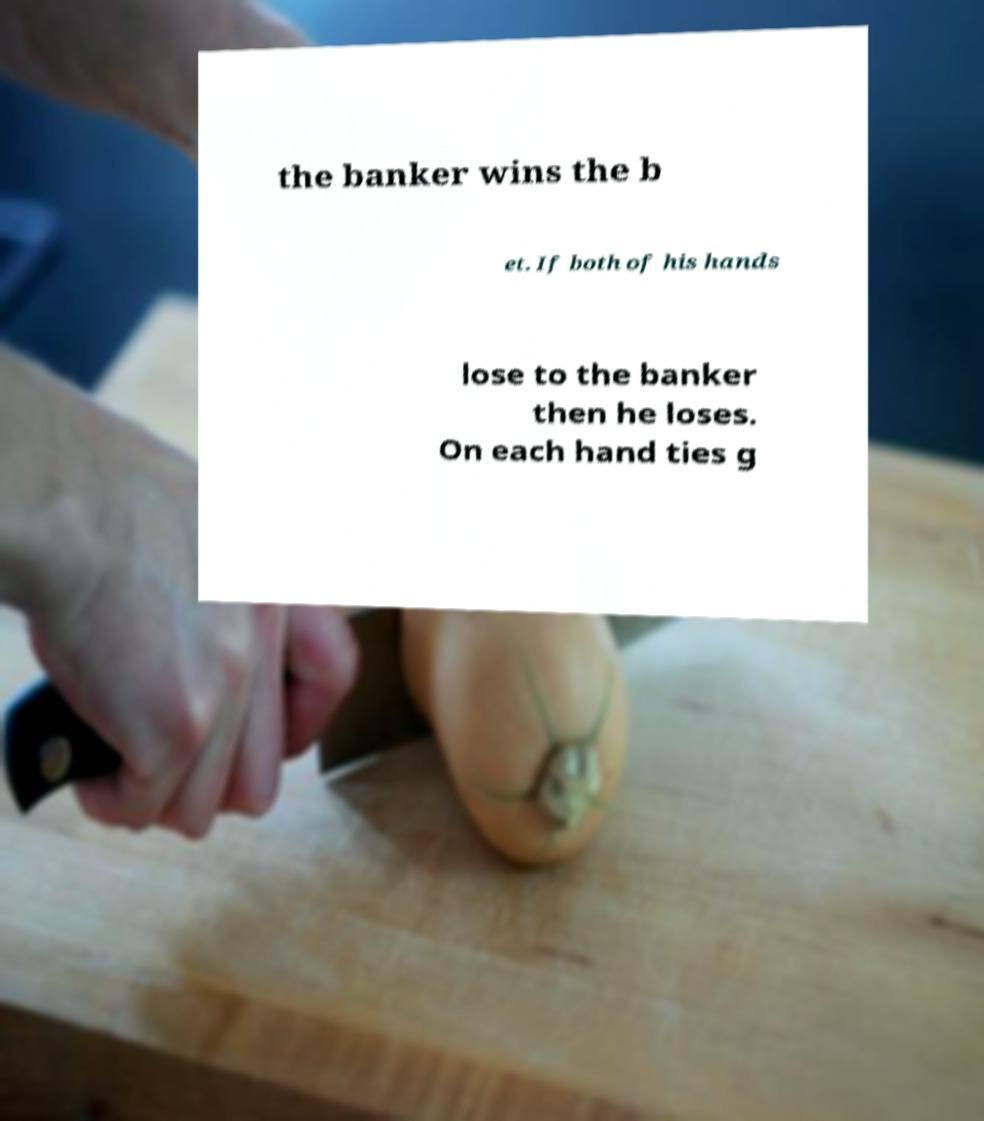Can you accurately transcribe the text from the provided image for me? the banker wins the b et. If both of his hands lose to the banker then he loses. On each hand ties g 